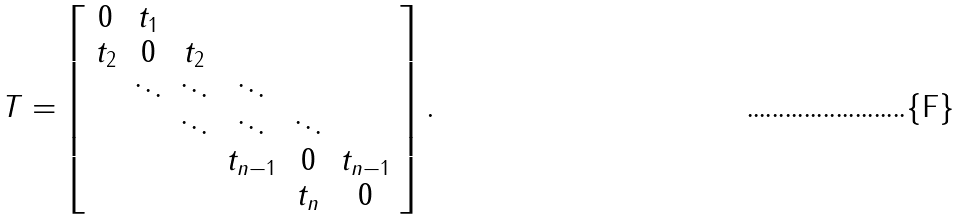<formula> <loc_0><loc_0><loc_500><loc_500>T = \left [ \begin{array} { c c c c c c } 0 & t _ { 1 } \\ t _ { 2 } & 0 & t _ { 2 } \\ & \ddots & \ddots & \ddots \\ & & \ddots & \ddots & \ddots \\ & & & t _ { n - 1 } & 0 & t _ { n - 1 } \\ & & & & t _ { n } & 0 \end{array} \right ] .</formula> 